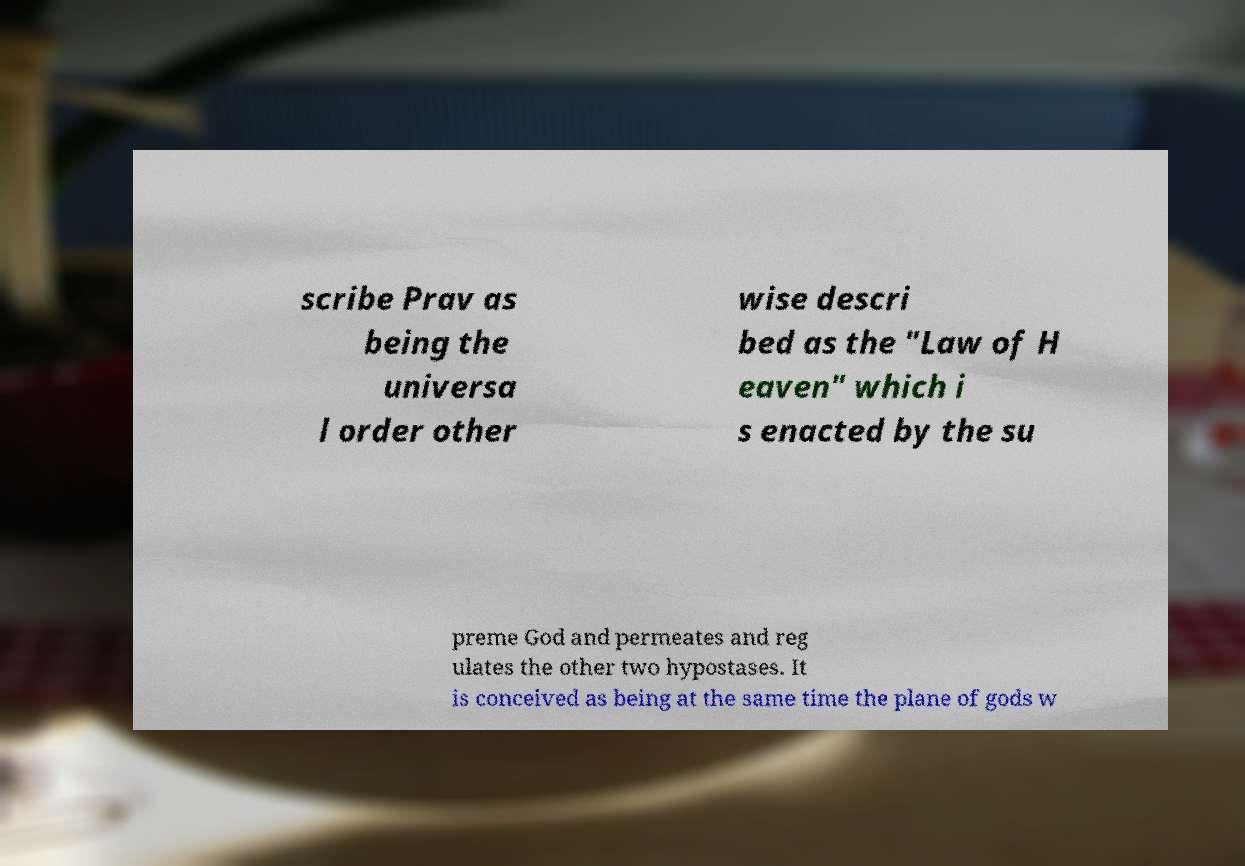Please read and relay the text visible in this image. What does it say? scribe Prav as being the universa l order other wise descri bed as the "Law of H eaven" which i s enacted by the su preme God and permeates and reg ulates the other two hypostases. It is conceived as being at the same time the plane of gods w 